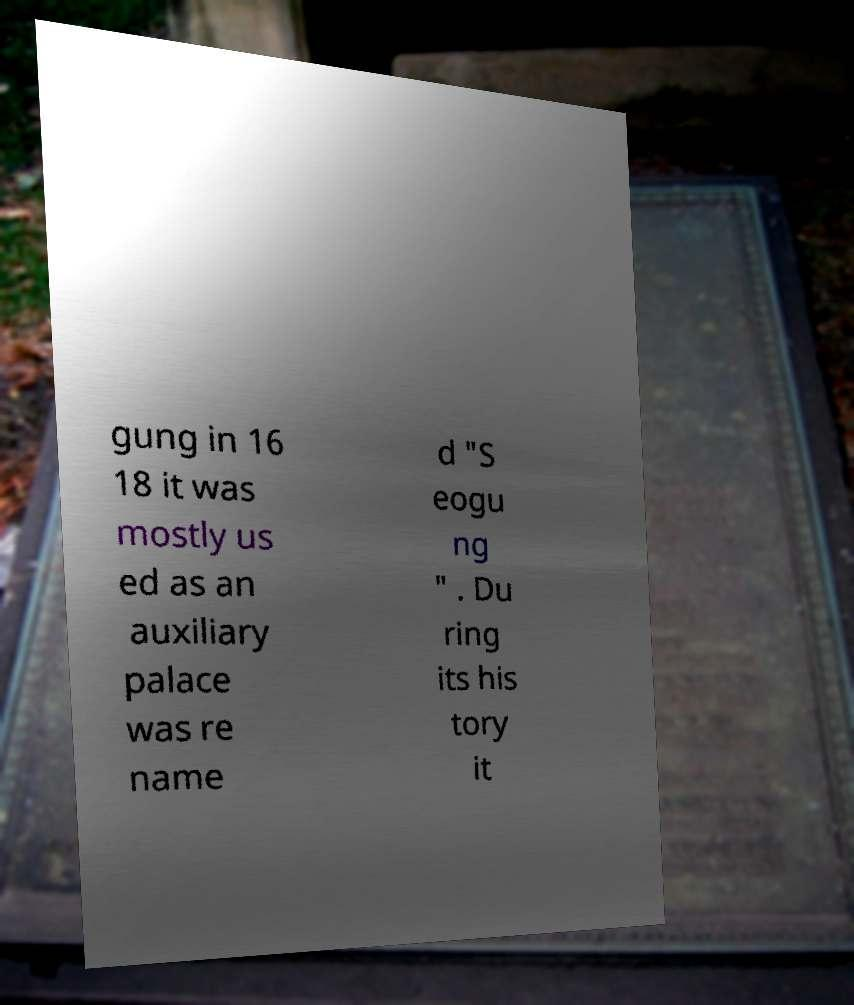Could you assist in decoding the text presented in this image and type it out clearly? gung in 16 18 it was mostly us ed as an auxiliary palace was re name d "S eogu ng " . Du ring its his tory it 